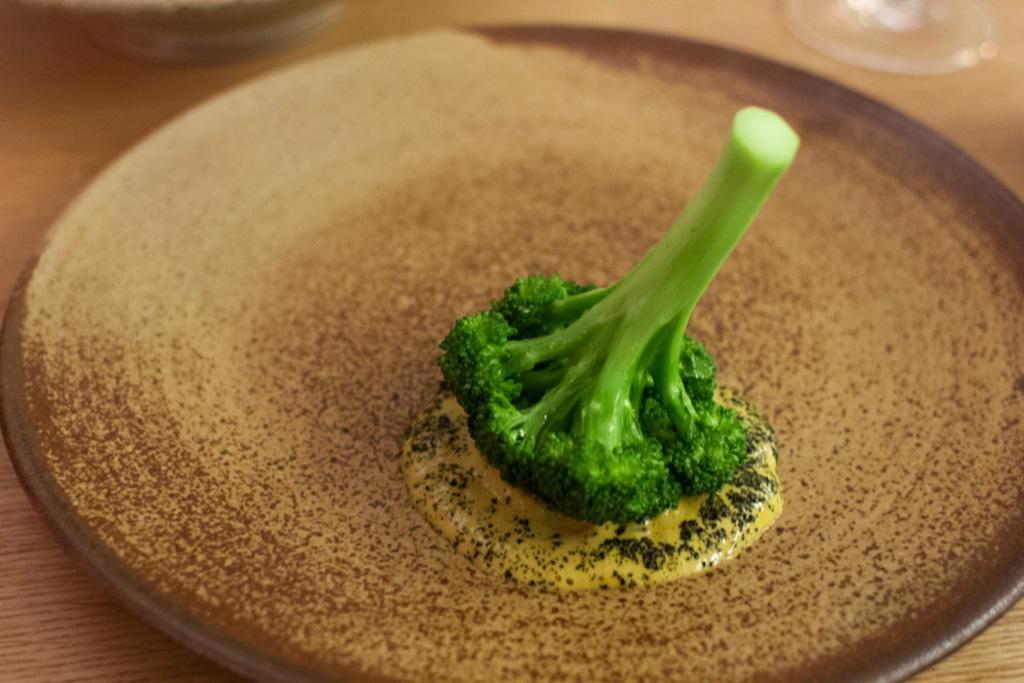Describe this image in one or two sentences. In this image, we can see a broccoli on the plate. 